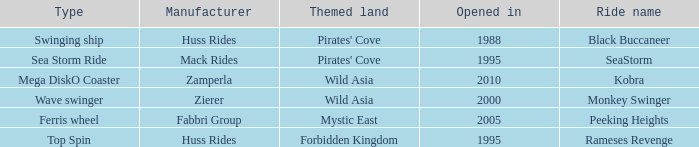What type of ride is Rameses Revenge? Top Spin. 